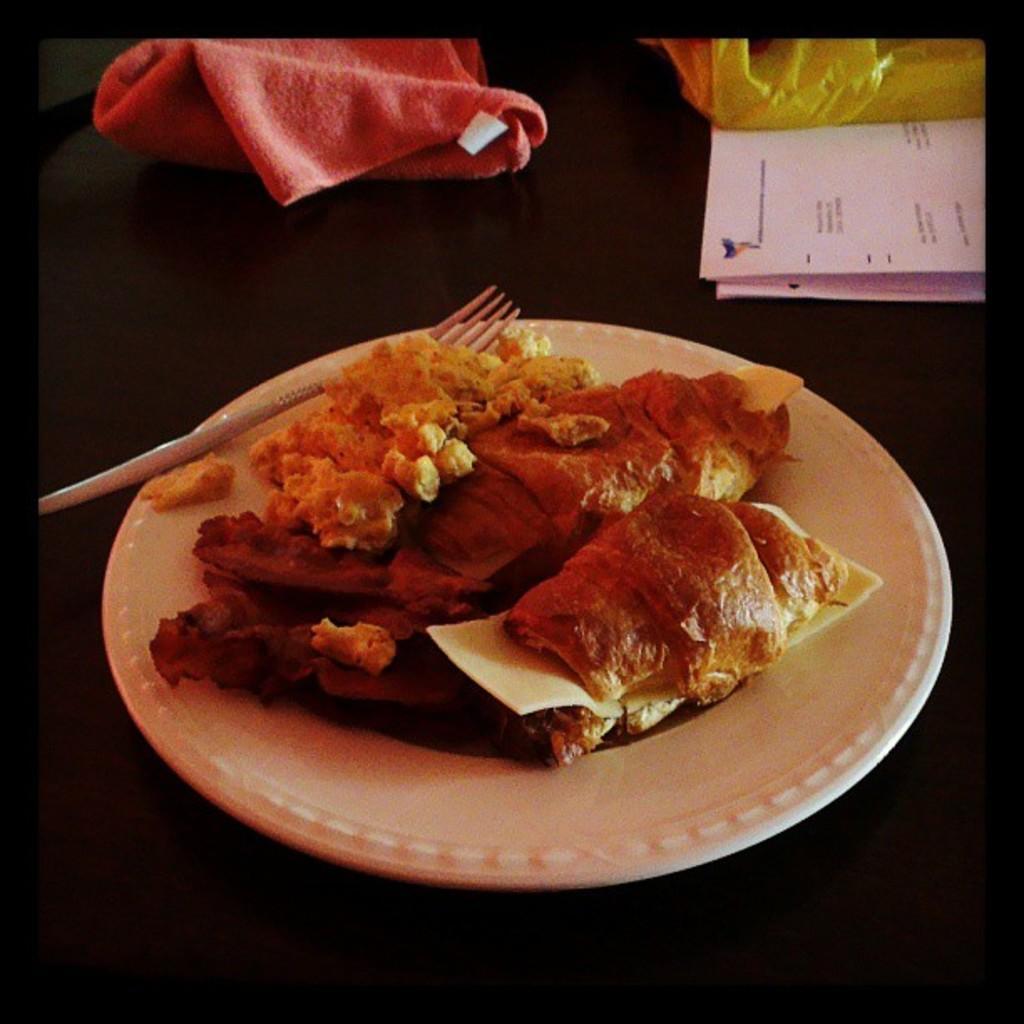Describe this image in one or two sentences. In this image there is a table, on that table there are papers, clothes, plate in that plate there is food item and there is a fork. 